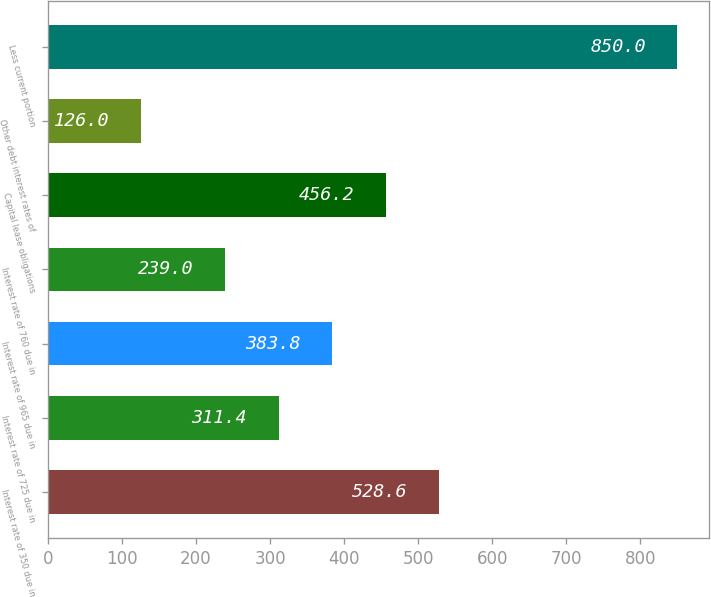Convert chart to OTSL. <chart><loc_0><loc_0><loc_500><loc_500><bar_chart><fcel>Interest rate of 350 due in<fcel>Interest rate of 725 due in<fcel>Interest rate of 965 due in<fcel>Interest rate of 760 due in<fcel>Capital lease obligations<fcel>Other debt interest rates of<fcel>Less current portion<nl><fcel>528.6<fcel>311.4<fcel>383.8<fcel>239<fcel>456.2<fcel>126<fcel>850<nl></chart> 